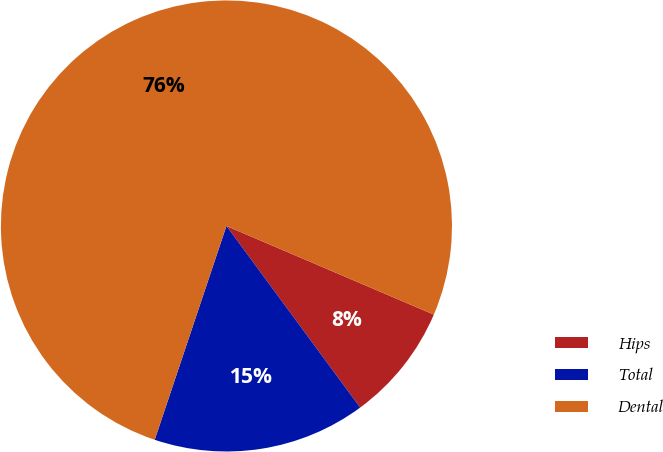Convert chart. <chart><loc_0><loc_0><loc_500><loc_500><pie_chart><fcel>Hips<fcel>Total<fcel>Dental<nl><fcel>8.47%<fcel>15.25%<fcel>76.27%<nl></chart> 